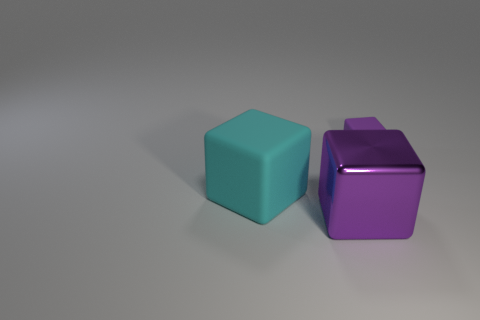What number of purple things are shiny blocks or cubes?
Your response must be concise. 2. The purple shiny cube has what size?
Offer a terse response. Large. How many metallic objects are green balls or large cubes?
Offer a terse response. 1. Is the number of large red rubber cylinders less than the number of big matte cubes?
Your answer should be very brief. Yes. How many other things are there of the same material as the big purple object?
Your answer should be very brief. 0. What size is the other rubber thing that is the same shape as the purple rubber object?
Offer a terse response. Large. Does the purple thing that is on the right side of the metal cube have the same material as the purple thing on the left side of the tiny object?
Your answer should be very brief. No. Is the number of big metallic blocks that are behind the large cyan rubber block less than the number of big green matte blocks?
Provide a succinct answer. No. Is there anything else that is the same shape as the tiny purple matte thing?
Your answer should be compact. Yes. What is the color of the other matte thing that is the same shape as the big cyan matte thing?
Your answer should be compact. Purple. 